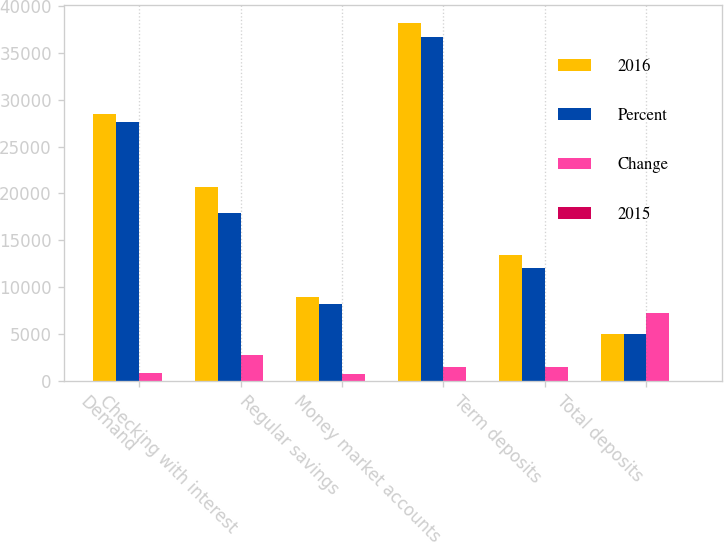Convert chart to OTSL. <chart><loc_0><loc_0><loc_500><loc_500><stacked_bar_chart><ecel><fcel>Demand<fcel>Checking with interest<fcel>Regular savings<fcel>Money market accounts<fcel>Term deposits<fcel>Total deposits<nl><fcel>2016<fcel>28472<fcel>20714<fcel>8964<fcel>38176<fcel>13478<fcel>5029<nl><fcel>Percent<fcel>27649<fcel>17921<fcel>8218<fcel>36727<fcel>12024<fcel>5029<nl><fcel>Change<fcel>823<fcel>2793<fcel>746<fcel>1449<fcel>1454<fcel>7265<nl><fcel>2015<fcel>3<fcel>16<fcel>9<fcel>4<fcel>12<fcel>7<nl></chart> 